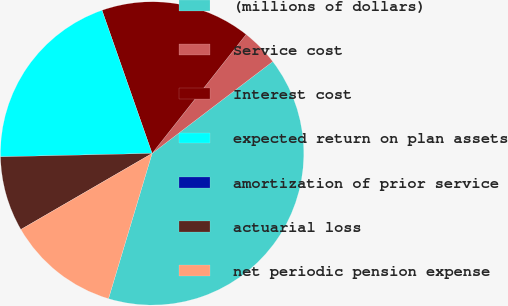Convert chart to OTSL. <chart><loc_0><loc_0><loc_500><loc_500><pie_chart><fcel>(millions of dollars)<fcel>Service cost<fcel>Interest cost<fcel>expected return on plan assets<fcel>amortization of prior service<fcel>actuarial loss<fcel>net periodic pension expense<nl><fcel>40.0%<fcel>4.0%<fcel>16.0%<fcel>20.0%<fcel>0.0%<fcel>8.0%<fcel>12.0%<nl></chart> 